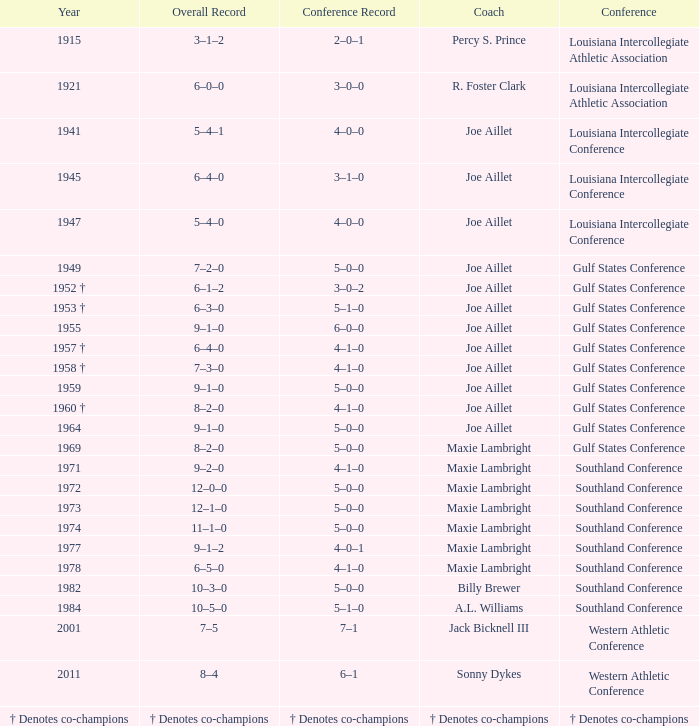What is the conference record for the year of 1971? 4–1–0. 